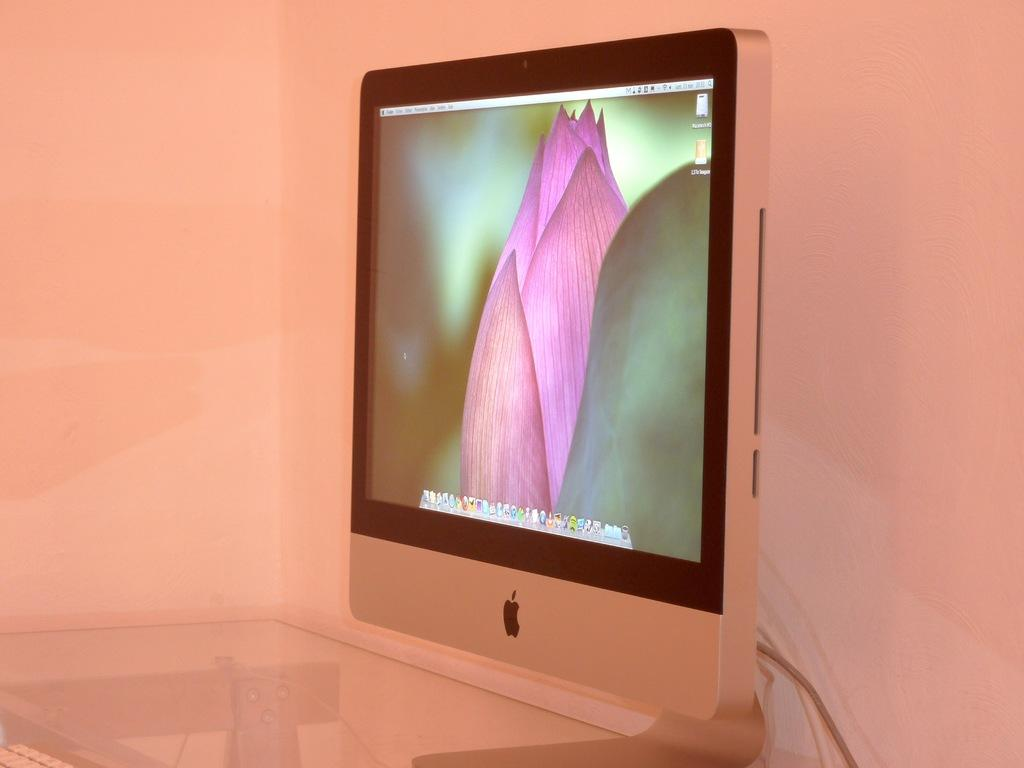What electronic device is visible in the image? There is a monitor in the image. Where is the monitor located? The monitor is placed on a table. What can be seen in the background of the image? There is a wall in the background of the image. How does the monitor maintain its balance on the table in the image? The monitor maintains its balance on the table through its built-in stand, not through any trick or thread. 